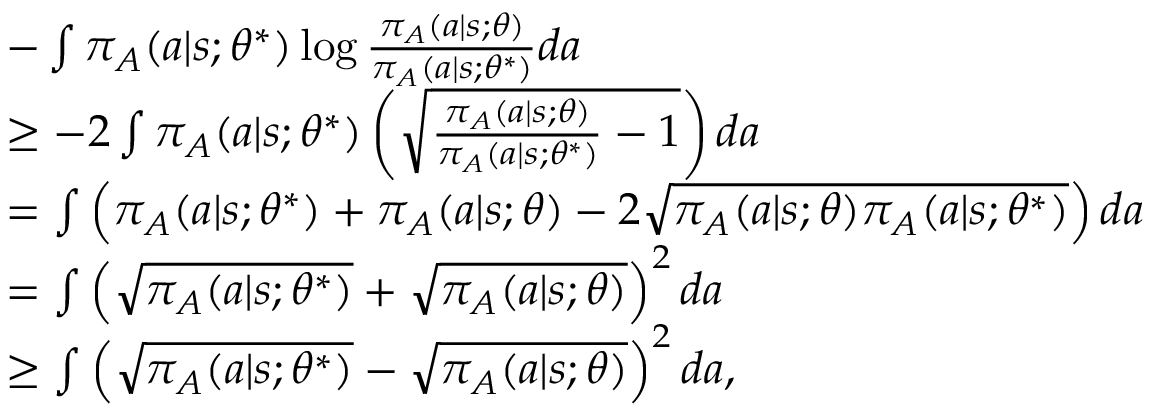Convert formula to latex. <formula><loc_0><loc_0><loc_500><loc_500>\begin{array} { r l } & { - \int \pi _ { A } ( a | s ; \theta ^ { \ast } ) \log \frac { \pi _ { A } ( a | s ; \theta ) } { \pi _ { A } ( a | s ; \theta ^ { \ast } ) } d a } \\ & { \geq - 2 \int \pi _ { A } ( a | s ; \theta ^ { * } ) \left ( \sqrt { \frac { \pi _ { A } ( a | s ; \theta ) } { \pi _ { A } ( a | s ; \theta ^ { * } ) } - 1 } \right ) d a } \\ & { = \int \left ( \pi _ { A } ( a | s ; \theta ^ { * } ) + \pi _ { A } ( a | s ; \theta ) - 2 \sqrt { \pi _ { A } ( a | s ; \theta ) \pi _ { A } ( a | s ; \theta ^ { * } ) } \right ) d a } \\ & { = \int \left ( \sqrt { \pi _ { A } ( a | s ; \theta ^ { * } ) } + \sqrt { \pi _ { A } ( a | s ; \theta ) } \right ) ^ { 2 } d a } \\ & { \geq \int \left ( \sqrt { \pi _ { A } ( a | s ; \theta ^ { * } ) } - \sqrt { \pi _ { A } ( a | s ; \theta ) } \right ) ^ { 2 } d a , } \end{array}</formula> 